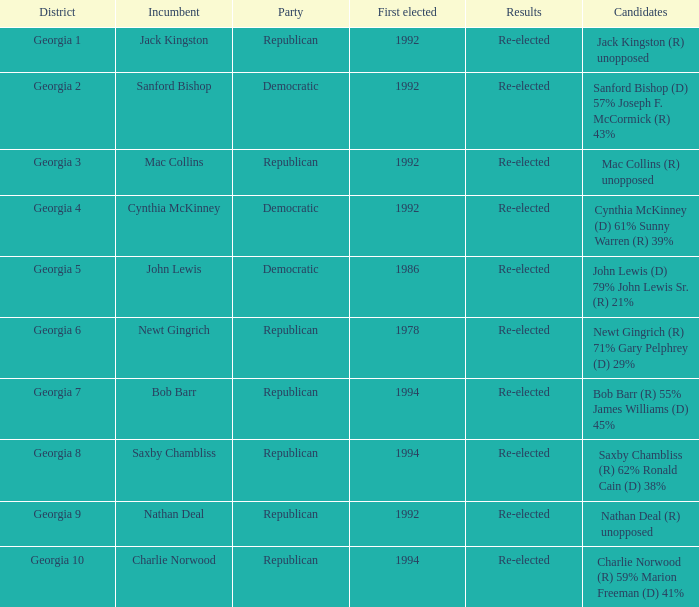Who were the candidates in the election where Saxby Chambliss was the incumbent? Saxby Chambliss (R) 62% Ronald Cain (D) 38%. 